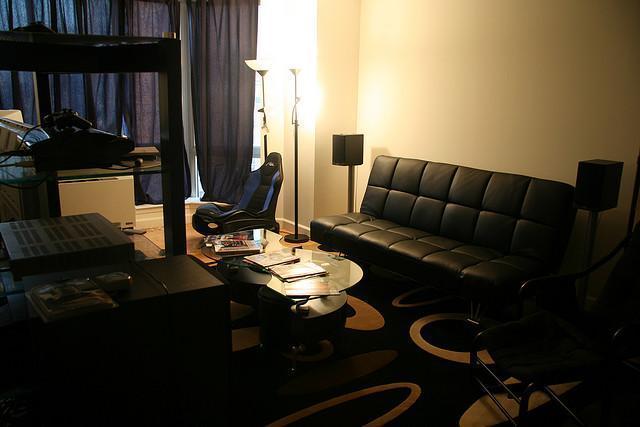How many chairs are in the photo?
Give a very brief answer. 2. How many women are wearing blue sweaters?
Give a very brief answer. 0. 